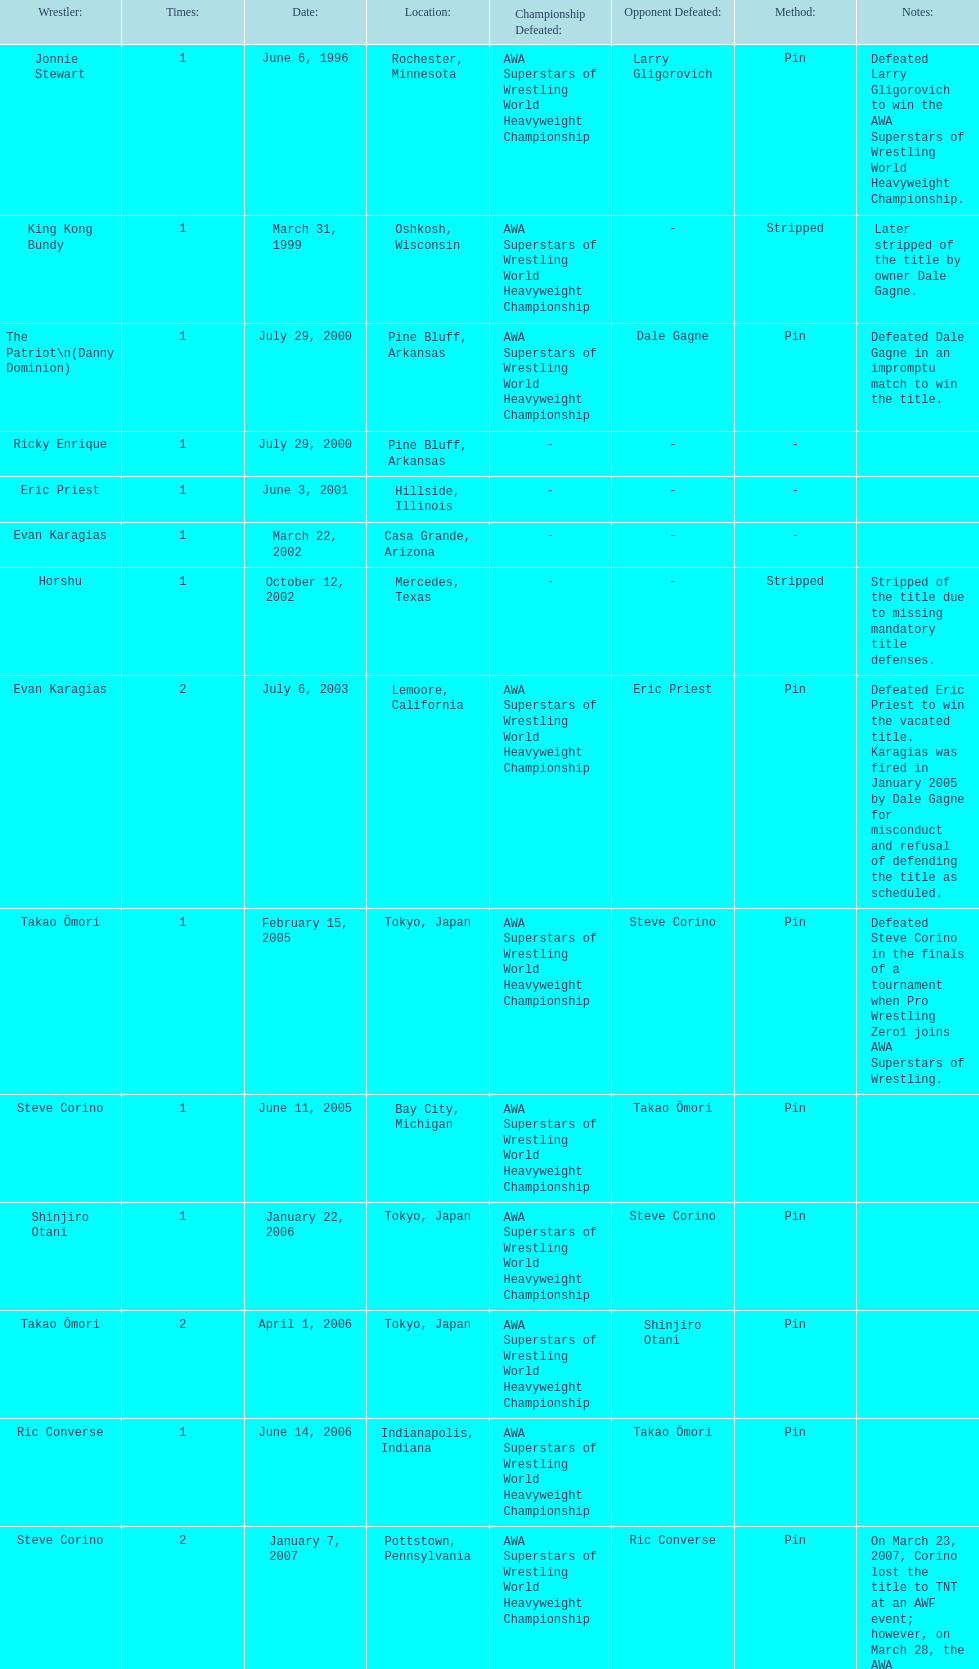Who is the last wrestler to hold the title? The Honky Tonk Man. 